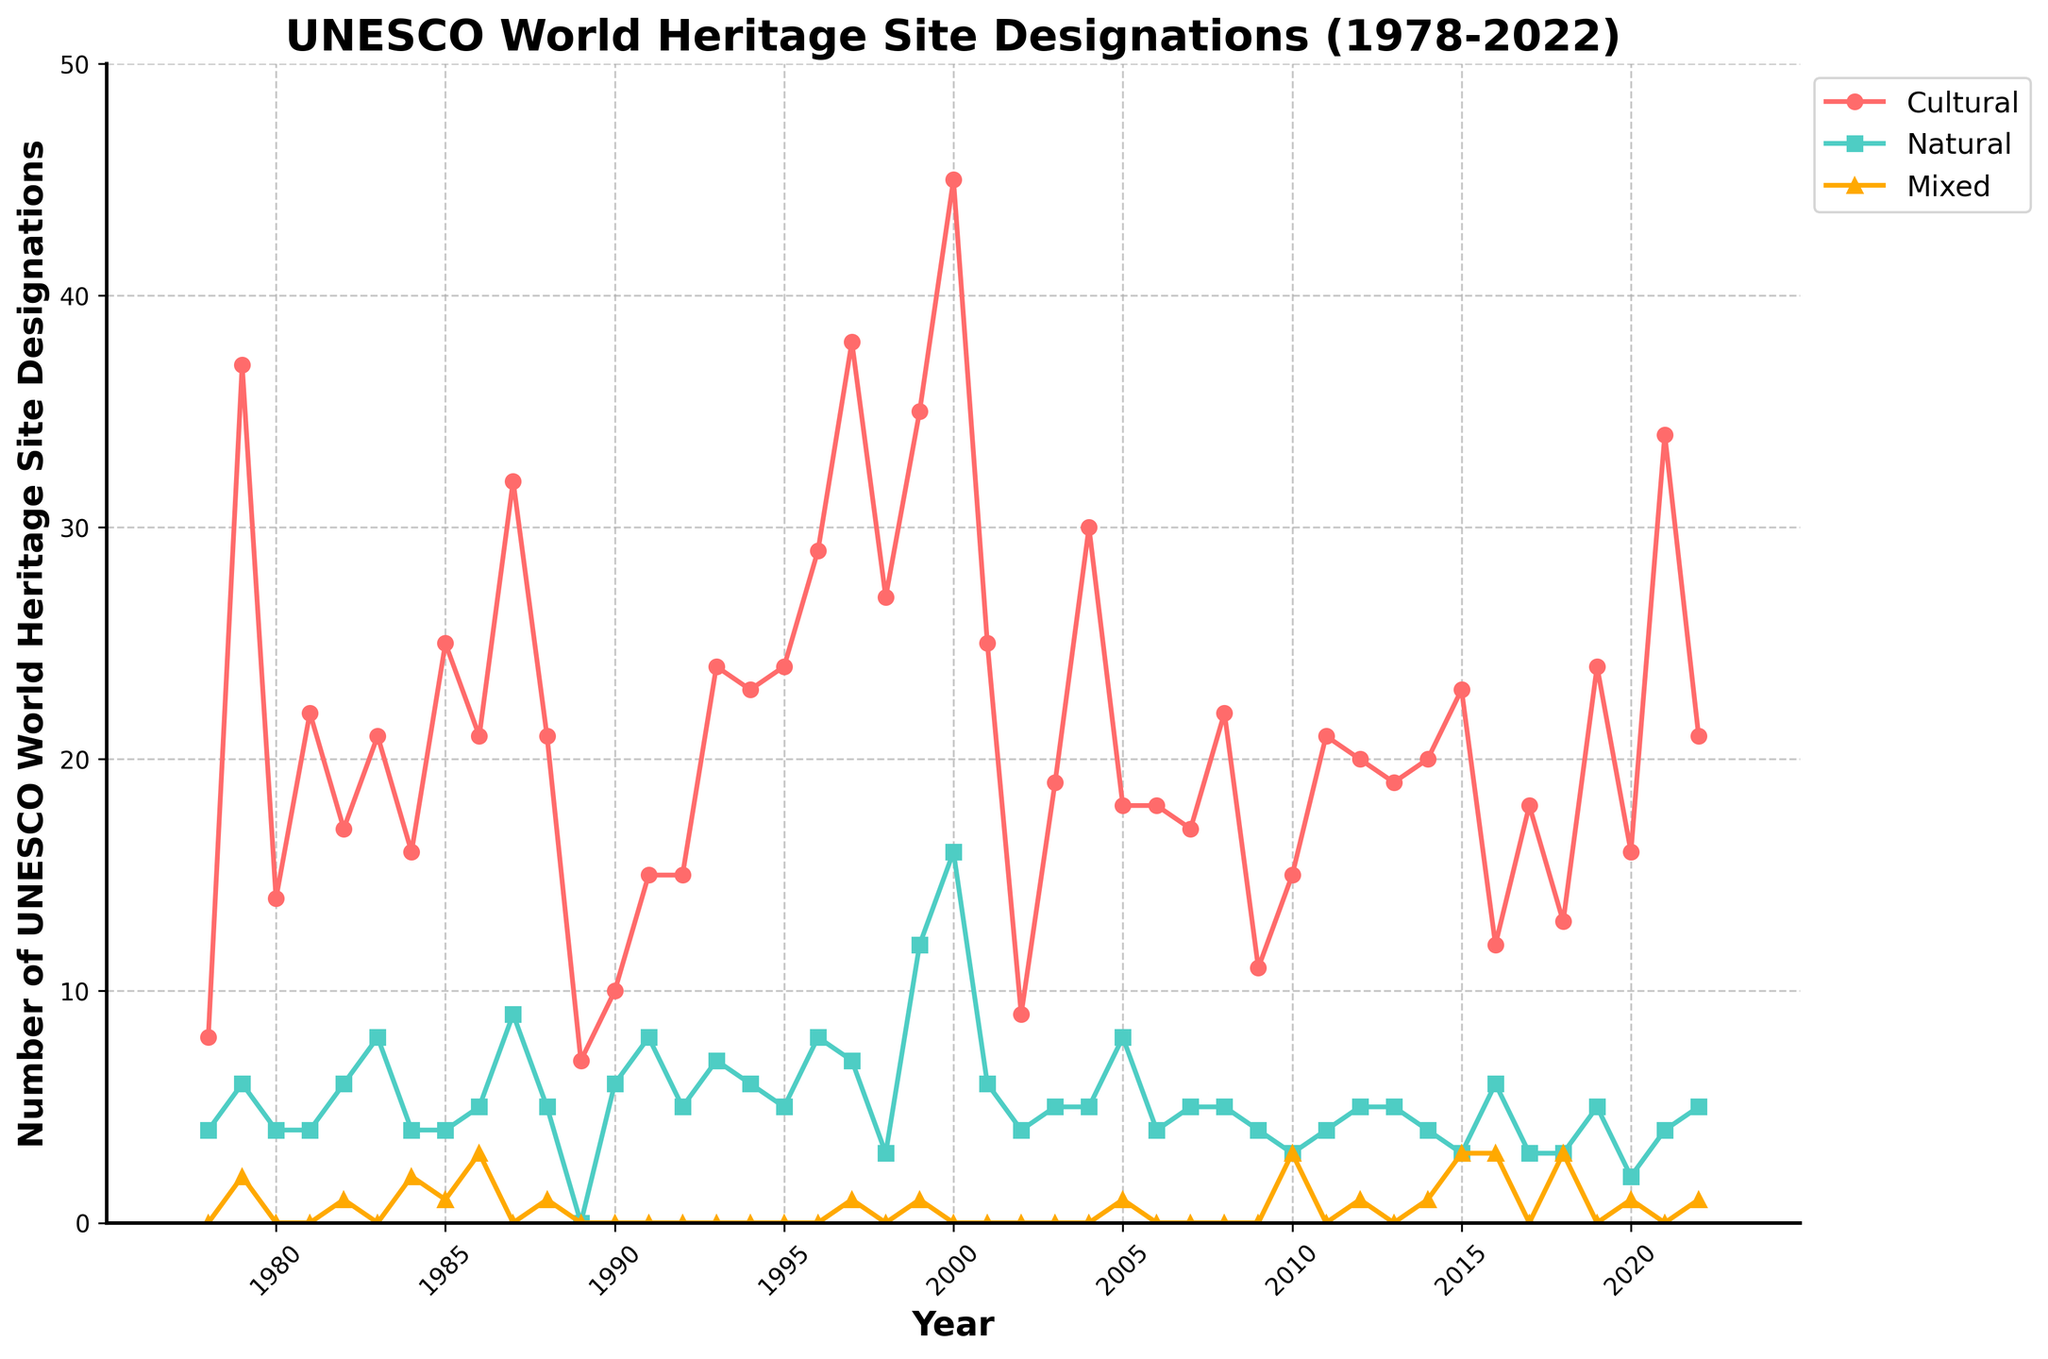What is the highest number of Cultural site designations in a single year? Look at the red line representing Cultural sites. The highest point indicates the maximum number of designations, which occurs in the year 2000. The number is 45.
Answer: 45 In which year did Natural site designations peak? Check the green line representing Natural sites. The highest peak is in the year 2000.
Answer: 2000 How many more Cultural sites were designated in 1997 compared to 1978? Find the number of Cultural designations for 1997 (38) and 1978 (8). Subtract the 1978 value from 1997. 38 - 8 = 30.
Answer: 30 Which category has the least number of designations overall? Compare the heights of the three lines (red for Cultural, green for Natural, and yellow for Mixed). The yellow line representing Mixed sites is the lowest overall.
Answer: Mixed In what year were Mixed sites first designated? Look for the first non-zero value in the yellow line representing Mixed sites. This occurs in 1979.
Answer: 1979 During which year did all three categories have designation counts of exactly 4? Check the years where all three lines (red for Cultural, green for Natural, and yellow for Mixed) meet at the value of 4. This occurs in 1984.
Answer: 1984 How many total UNESCO World Heritage Site designations were there in 2001? Add the counts for each category in 2001: Cultural (25), Natural (6), and Mixed (0). 25 + 6 + 0 = 31.
Answer: 31 Which category saw a significant drop in designations in 1989 compared to the previous year? From 1988 to 1989, the red line representing Cultural sites drops sharply from 21 to 7, indicating a significant reduction.
Answer: Cultural What is the total number of Natural sites designated from 1978 to 1980? Sum the Natural designations for the years 1978 (4), 1979 (6), and 1980 (4). 4 + 6 + 4 = 14.
Answer: 14 